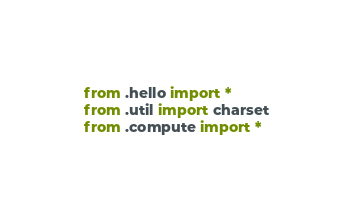Convert code to text. <code><loc_0><loc_0><loc_500><loc_500><_Python_>
from .hello import *
from .util import charset
from .compute import *</code> 